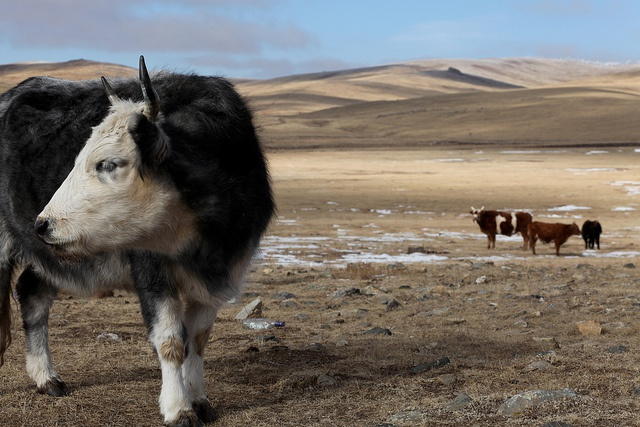Describe the objects in this image and their specific colors. I can see cow in darkgray, black, and gray tones, cow in darkgray, black, maroon, and gray tones, cow in darkgray, black, maroon, and gray tones, and cow in darkgray, black, maroon, and gray tones in this image. 